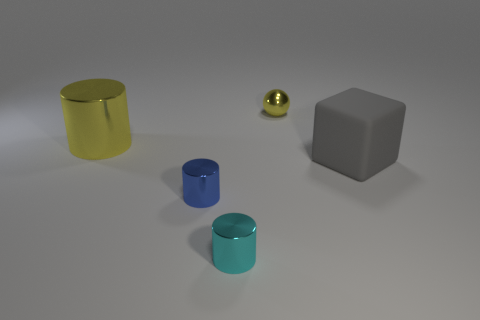Are there any large yellow things that have the same material as the ball?
Provide a succinct answer. Yes. What material is the other thing that is the same size as the rubber thing?
Your answer should be very brief. Metal. The thing on the right side of the yellow object that is right of the big thing to the left of the yellow ball is what color?
Give a very brief answer. Gray. There is a large object that is in front of the big yellow shiny object; is its shape the same as the yellow object to the left of the small blue shiny object?
Provide a succinct answer. No. What number of purple rubber cylinders are there?
Provide a short and direct response. 0. There is a shiny cylinder that is the same size as the gray cube; what color is it?
Your answer should be compact. Yellow. Are the large object left of the gray rubber cube and the thing in front of the blue metallic cylinder made of the same material?
Make the answer very short. Yes. There is a object right of the tiny object behind the large cube; what is its size?
Keep it short and to the point. Large. What material is the cylinder behind the gray object?
Your response must be concise. Metal. What number of objects are metallic cylinders in front of the gray object or tiny things that are behind the big gray object?
Your answer should be compact. 3. 